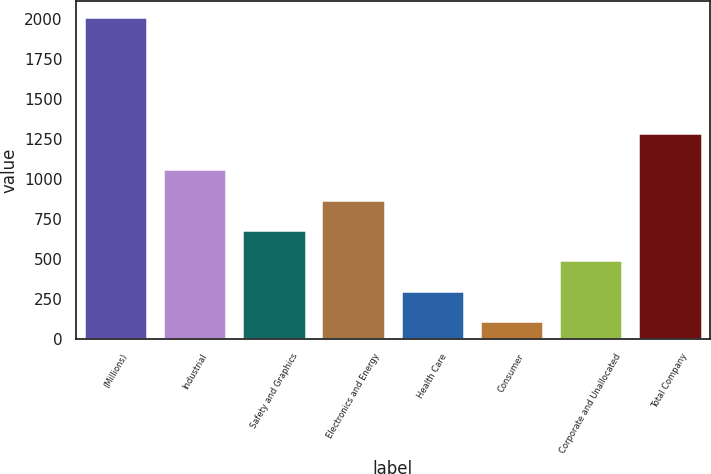Convert chart. <chart><loc_0><loc_0><loc_500><loc_500><bar_chart><fcel>(Millions)<fcel>Industrial<fcel>Safety and Graphics<fcel>Electronics and Energy<fcel>Health Care<fcel>Consumer<fcel>Corporate and Unallocated<fcel>Total Company<nl><fcel>2012<fcel>1061<fcel>680.6<fcel>870.8<fcel>300.2<fcel>110<fcel>490.4<fcel>1288<nl></chart> 